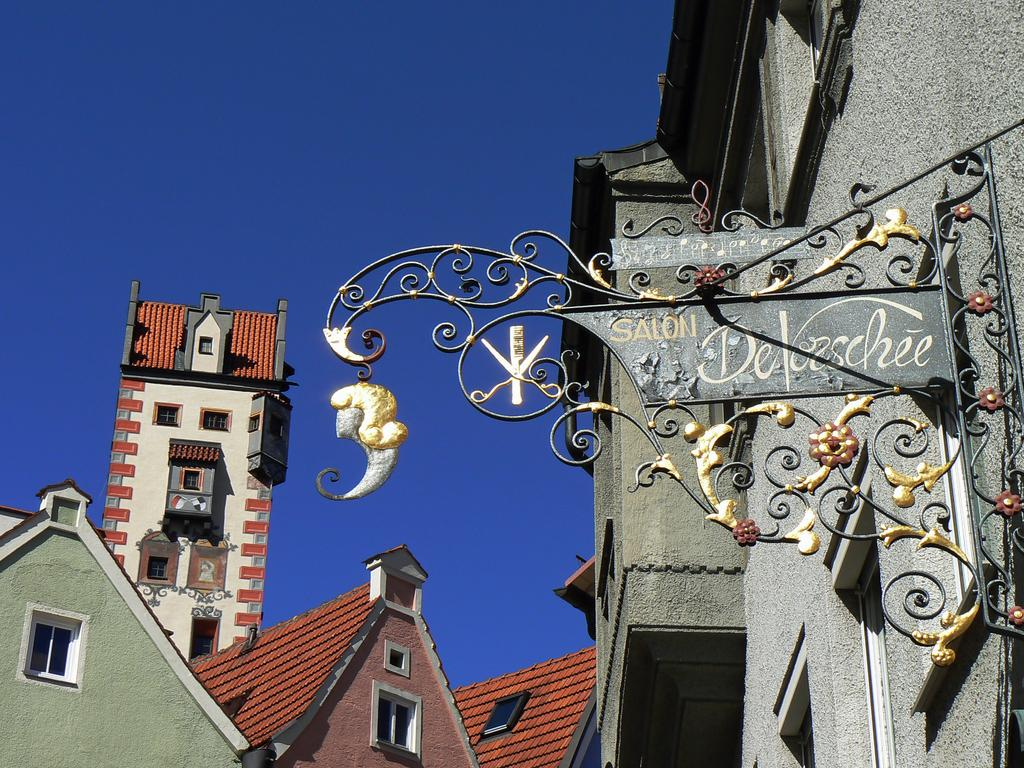What type of structures can be seen in the image? There are buildings in the image. What object is present in the image that is not a building? There is a board in the image. What is written or displayed on the board? There is text on the board. What can be seen above the buildings and board in the image? The sky is visible at the top of the image. What caption is written below the image? There is no caption written below the image; the provided facts only describe the contents of the image itself. 